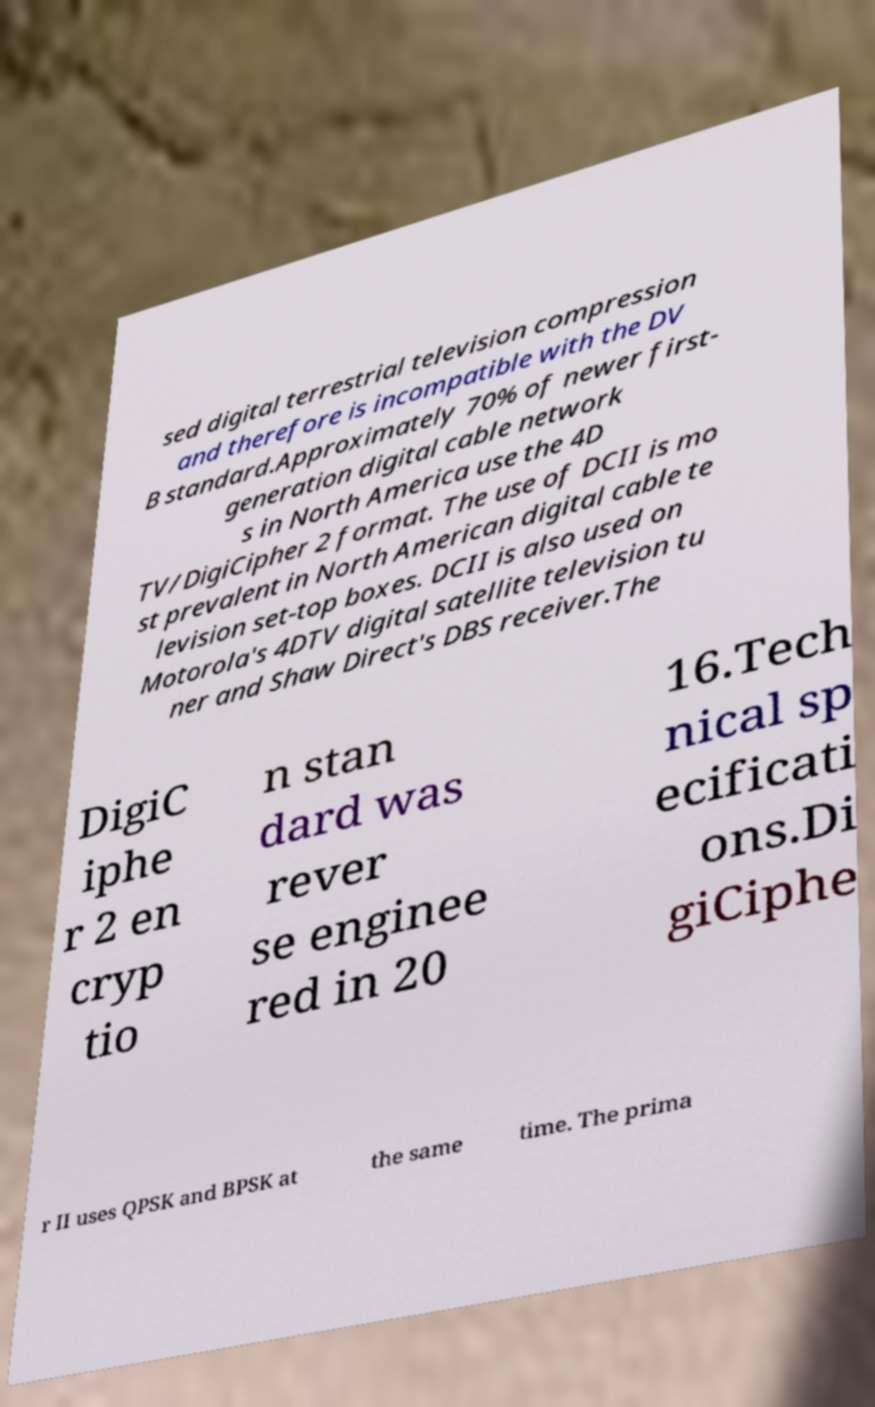Could you extract and type out the text from this image? sed digital terrestrial television compression and therefore is incompatible with the DV B standard.Approximately 70% of newer first- generation digital cable network s in North America use the 4D TV/DigiCipher 2 format. The use of DCII is mo st prevalent in North American digital cable te levision set-top boxes. DCII is also used on Motorola's 4DTV digital satellite television tu ner and Shaw Direct's DBS receiver.The DigiC iphe r 2 en cryp tio n stan dard was rever se enginee red in 20 16.Tech nical sp ecificati ons.Di giCiphe r II uses QPSK and BPSK at the same time. The prima 